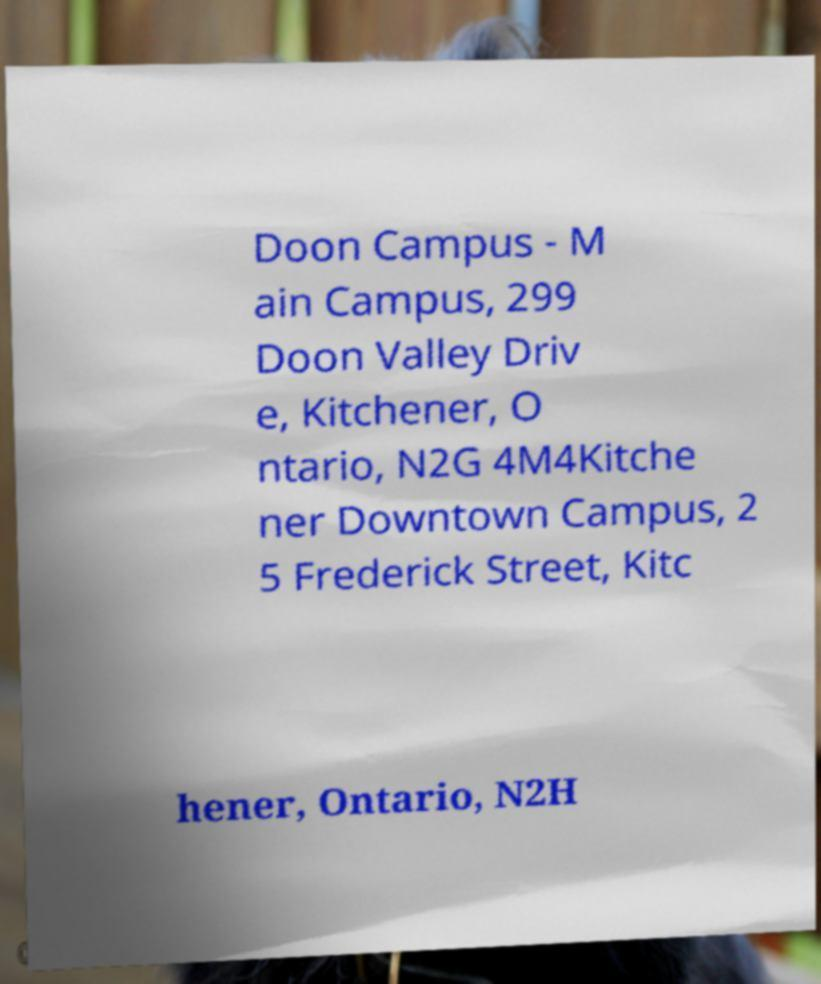For documentation purposes, I need the text within this image transcribed. Could you provide that? Doon Campus - M ain Campus, 299 Doon Valley Driv e, Kitchener, O ntario, N2G 4M4Kitche ner Downtown Campus, 2 5 Frederick Street, Kitc hener, Ontario, N2H 